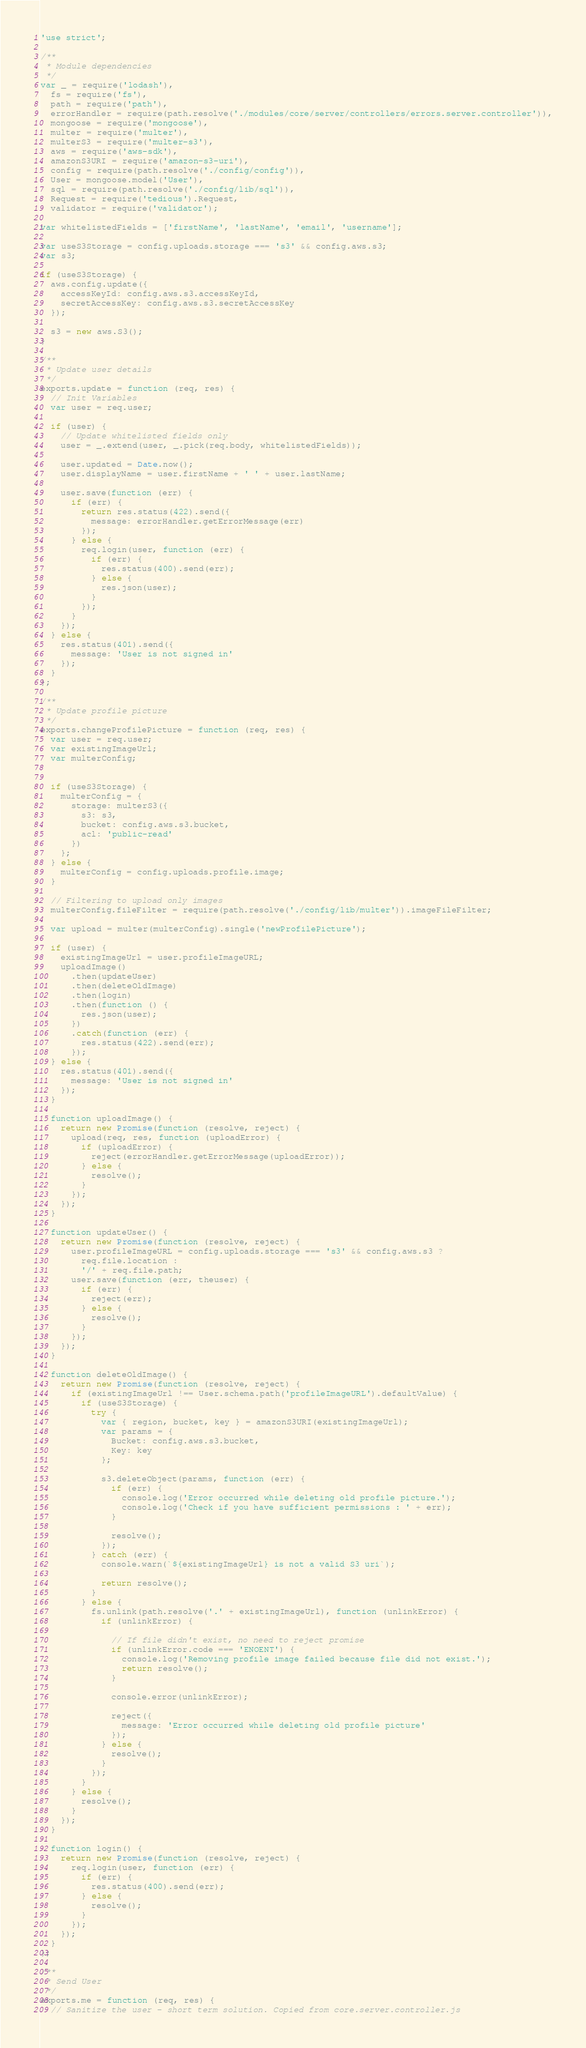<code> <loc_0><loc_0><loc_500><loc_500><_JavaScript_>'use strict';

/**
 * Module dependencies
 */
var _ = require('lodash'),
  fs = require('fs'),
  path = require('path'),
  errorHandler = require(path.resolve('./modules/core/server/controllers/errors.server.controller')),
  mongoose = require('mongoose'),
  multer = require('multer'),
  multerS3 = require('multer-s3'),
  aws = require('aws-sdk'),
  amazonS3URI = require('amazon-s3-uri'),
  config = require(path.resolve('./config/config')),
  User = mongoose.model('User'),
  sql = require(path.resolve('./config/lib/sql')),
  Request = require('tedious').Request,
  validator = require('validator');

var whitelistedFields = ['firstName', 'lastName', 'email', 'username'];

var useS3Storage = config.uploads.storage === 's3' && config.aws.s3;
var s3;

if (useS3Storage) {
  aws.config.update({
    accessKeyId: config.aws.s3.accessKeyId,
    secretAccessKey: config.aws.s3.secretAccessKey
  });

  s3 = new aws.S3();
}

/**
 * Update user details
 */
exports.update = function (req, res) {
  // Init Variables
  var user = req.user;

  if (user) {
    // Update whitelisted fields only
    user = _.extend(user, _.pick(req.body, whitelistedFields));

    user.updated = Date.now();
    user.displayName = user.firstName + ' ' + user.lastName;

    user.save(function (err) {
      if (err) {
        return res.status(422).send({
          message: errorHandler.getErrorMessage(err)
        });
      } else {
        req.login(user, function (err) {
          if (err) {
            res.status(400).send(err);
          } else {
            res.json(user);
          }
        });
      }
    });
  } else {
    res.status(401).send({
      message: 'User is not signed in'
    });
  }
};

/**
 * Update profile picture
 */
exports.changeProfilePicture = function (req, res) {
  var user = req.user;
  var existingImageUrl;
  var multerConfig;


  if (useS3Storage) {
    multerConfig = {
      storage: multerS3({
        s3: s3,
        bucket: config.aws.s3.bucket,
        acl: 'public-read'
      })
    };
  } else {
    multerConfig = config.uploads.profile.image;
  }

  // Filtering to upload only images
  multerConfig.fileFilter = require(path.resolve('./config/lib/multer')).imageFileFilter;

  var upload = multer(multerConfig).single('newProfilePicture');

  if (user) {
    existingImageUrl = user.profileImageURL;
    uploadImage()
      .then(updateUser)
      .then(deleteOldImage)
      .then(login)
      .then(function () {
        res.json(user);
      })
      .catch(function (err) {
        res.status(422).send(err);
      });
  } else {
    res.status(401).send({
      message: 'User is not signed in'
    });
  }

  function uploadImage() {
    return new Promise(function (resolve, reject) {
      upload(req, res, function (uploadError) {
        if (uploadError) {
          reject(errorHandler.getErrorMessage(uploadError));
        } else {
          resolve();
        }
      });
    });
  }

  function updateUser() {
    return new Promise(function (resolve, reject) {
      user.profileImageURL = config.uploads.storage === 's3' && config.aws.s3 ?
        req.file.location :
        '/' + req.file.path;
      user.save(function (err, theuser) {
        if (err) {
          reject(err);
        } else {
          resolve();
        }
      });
    });
  }

  function deleteOldImage() {
    return new Promise(function (resolve, reject) {
      if (existingImageUrl !== User.schema.path('profileImageURL').defaultValue) {
        if (useS3Storage) {
          try {
            var { region, bucket, key } = amazonS3URI(existingImageUrl);
            var params = {
              Bucket: config.aws.s3.bucket,
              Key: key
            };

            s3.deleteObject(params, function (err) {
              if (err) {
                console.log('Error occurred while deleting old profile picture.');
                console.log('Check if you have sufficient permissions : ' + err);
              }

              resolve();
            });
          } catch (err) {
            console.warn(`${existingImageUrl} is not a valid S3 uri`);

            return resolve();
          }
        } else {
          fs.unlink(path.resolve('.' + existingImageUrl), function (unlinkError) {
            if (unlinkError) {

              // If file didn't exist, no need to reject promise
              if (unlinkError.code === 'ENOENT') {
                console.log('Removing profile image failed because file did not exist.');
                return resolve();
              }

              console.error(unlinkError);

              reject({
                message: 'Error occurred while deleting old profile picture'
              });
            } else {
              resolve();
            }
          });
        }
      } else {
        resolve();
      }
    });
  }

  function login() {
    return new Promise(function (resolve, reject) {
      req.login(user, function (err) {
        if (err) {
          res.status(400).send(err);
        } else {
          resolve();
        }
      });
    });
  }
};

/**
 * Send User
 */
exports.me = function (req, res) {
  // Sanitize the user - short term solution. Copied from core.server.controller.js</code> 